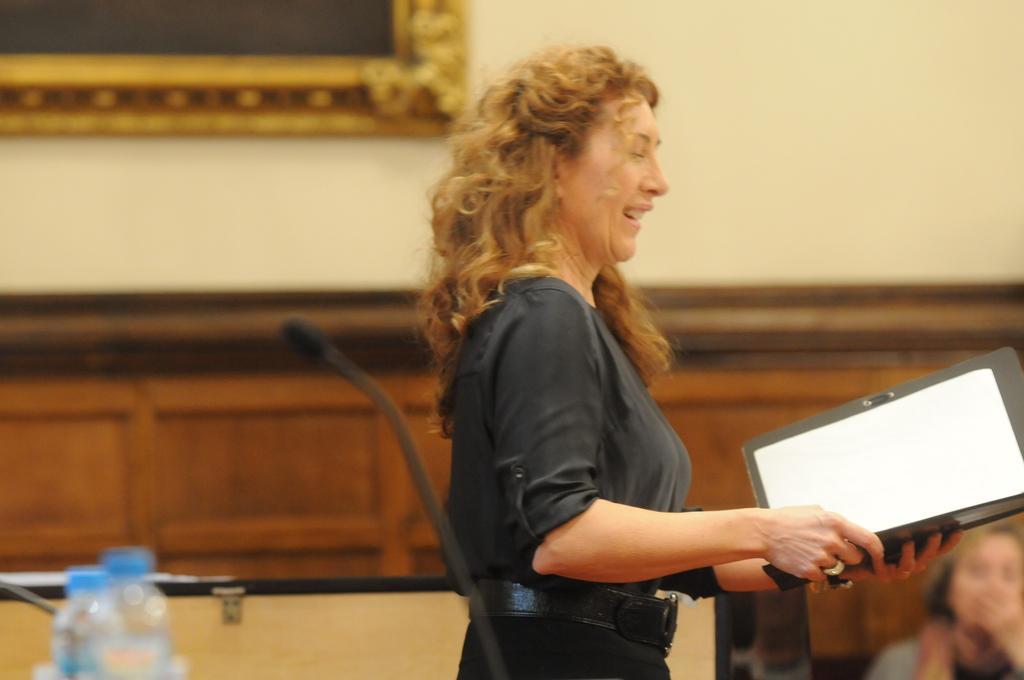Please provide a concise description of this image. In this picture we can see a woman is holding a file and in front of the woman there is a microphone and bottles. Behind the woman there is another person and a wall with a photo frame. 